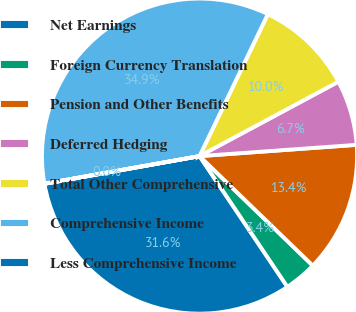Convert chart to OTSL. <chart><loc_0><loc_0><loc_500><loc_500><pie_chart><fcel>Net Earnings<fcel>Foreign Currency Translation<fcel>Pension and Other Benefits<fcel>Deferred Hedging<fcel>Total Other Comprehensive<fcel>Comprehensive Income<fcel>Less Comprehensive Income<nl><fcel>31.6%<fcel>3.35%<fcel>13.37%<fcel>6.69%<fcel>10.03%<fcel>34.94%<fcel>0.01%<nl></chart> 